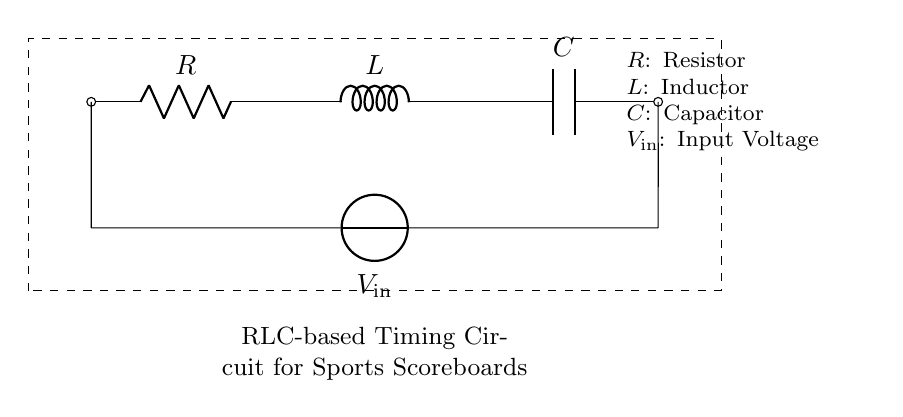What are the components in this circuit? The circuit contains three components: a resistor, an inductor, and a capacitor. These elements are clearly labeled in the diagram.
Answer: resistor, inductor, capacitor What is the input voltage labeled in the circuit? The input voltage is labeled as V in the diagram, indicating the voltage supplied to the circuit.
Answer: V in What is the order of components from left to right? The components are arranged in the following order from left to right: resistor, inductor, capacitor. This is directly observable based on their positions in the circuit.
Answer: resistor, inductor, capacitor What type of timing circuit is represented? The circuit is an RLC-based timing circuit. This is indicated in the description provided below the main circuit diagram.
Answer: RLC-based Why is this circuit suitable for timing applications? An RLC circuit combines resistance, inductance, and capacitance, enabling it to generate oscillations and delay signals, making it ideal for timing functions in devices such as scoreboards and clocks.
Answer: Generates oscillations What is the function of the resistor in this circuit? The resistor limits the current flowing through the circuit and controls the discharge rate of the capacitor, thereby influencing the timing characteristics of the circuit.
Answer: Limits current How does the presence of the inductor affect circuit behavior? The inductor stores energy in a magnetic field when current flows through it, providing the ability to sustain oscillations along with the capacitor, thus affecting the timing properties of the circuit.
Answer: Sustains oscillations 